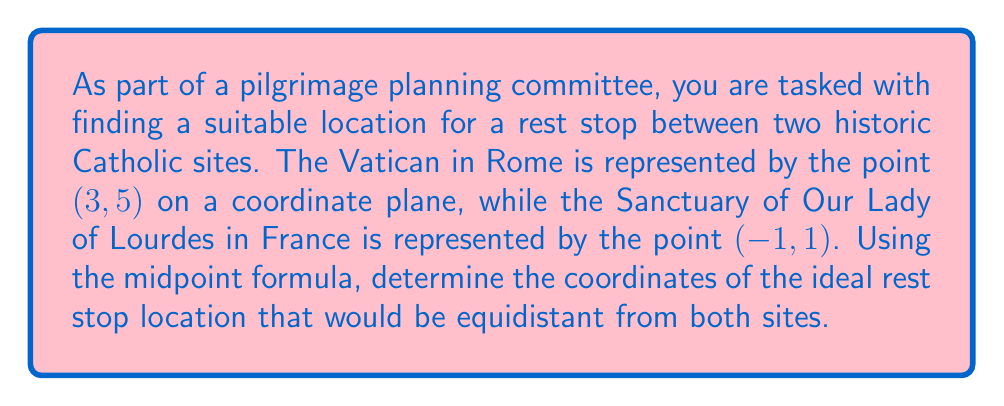Can you answer this question? To solve this problem, we need to use the midpoint formula. The midpoint formula calculates the point exactly halfway between two given points on a coordinate plane.

The midpoint formula is:

$$ \text{Midpoint} = \left(\frac{x_1 + x_2}{2}, \frac{y_1 + y_2}{2}\right) $$

Where $(x_1, y_1)$ is the first point and $(x_2, y_2)$ is the second point.

In our case:
- The Vatican: $(x_1, y_1) = (3, 5)$
- Sanctuary of Our Lady of Lourdes: $(x_2, y_2) = (-1, 1)$

Let's substitute these values into the formula:

$$ \text{Midpoint} = \left(\frac{3 + (-1)}{2}, \frac{5 + 1}{2}\right) $$

Simplifying:

$$ \text{Midpoint} = \left(\frac{2}{2}, \frac{6}{2}\right) $$

$$ \text{Midpoint} = (1, 3) $$

Therefore, the ideal location for the rest stop would be at the point (1, 3) on our coordinate plane.

[asy]
unitsize(1cm);
draw((-2,-1)--(4,6),gray);
draw((-2,0)--(4,0),gray);
draw((0,-1)--(0,6),gray);
dot((3,5));
dot((-1,1));
dot((1,3),red);
label("Vatican (3,5)", (3,5), NE);
label("Lourdes (-1,1)", (-1,1), SW);
label("Rest Stop (1,3)", (1,3), SE);
[/asy]
Answer: The coordinates of the ideal rest stop location are (1, 3). 